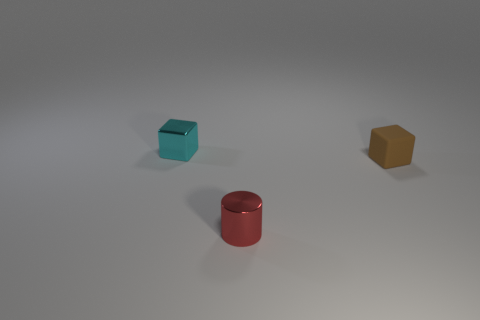There is a small brown object; what number of small red cylinders are on the left side of it?
Offer a very short reply. 1. The metal cube has what color?
Keep it short and to the point. Cyan. What number of small objects are either red things or matte objects?
Make the answer very short. 2. Is the color of the metal object that is in front of the brown thing the same as the metal thing on the left side of the red shiny object?
Your answer should be very brief. No. What number of other things are the same color as the cylinder?
Your answer should be very brief. 0. The red object in front of the cyan thing has what shape?
Offer a very short reply. Cylinder. Is the number of big gray rubber things less than the number of cyan things?
Provide a short and direct response. Yes. Do the block on the right side of the shiny cube and the tiny cylinder have the same material?
Offer a very short reply. No. Is there anything else that has the same size as the cyan thing?
Your response must be concise. Yes. There is a tiny cyan block; are there any cyan metal blocks in front of it?
Give a very brief answer. No. 